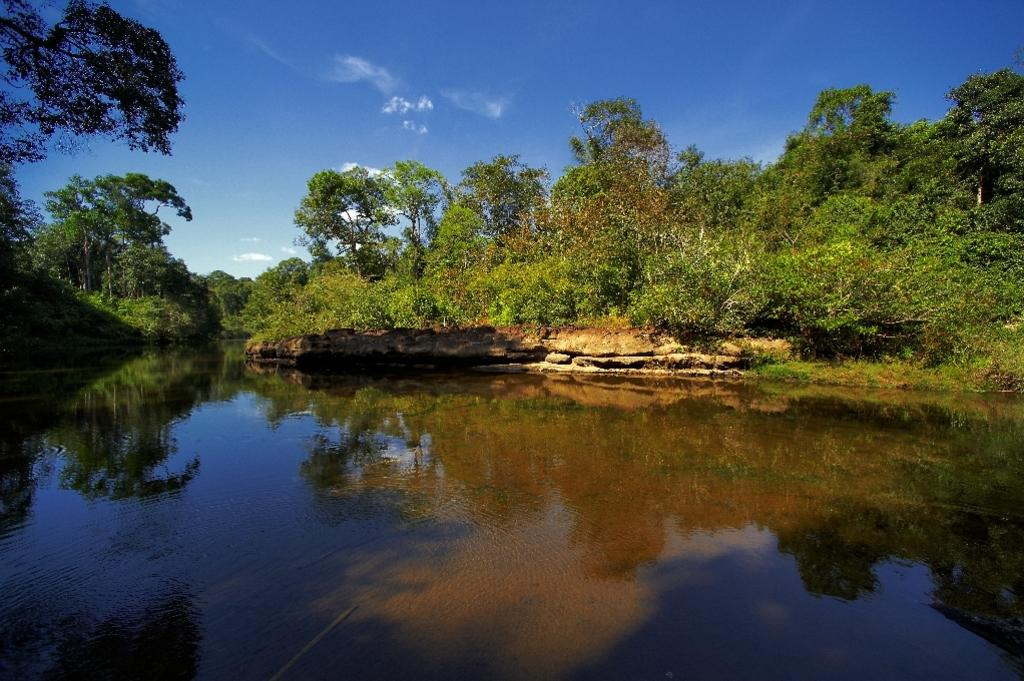What type of natural feature is present in the image? There is a river in the image. What can be seen surrounding the river? There are trees around the river. What is visible in the background of the image? The sky is visible in the background of the image. What grade does the station receive for its cleanliness in the image? There is no station present in the image, so it is not possible to evaluate its cleanliness or assign a grade. 